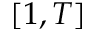<formula> <loc_0><loc_0><loc_500><loc_500>[ 1 , T ]</formula> 